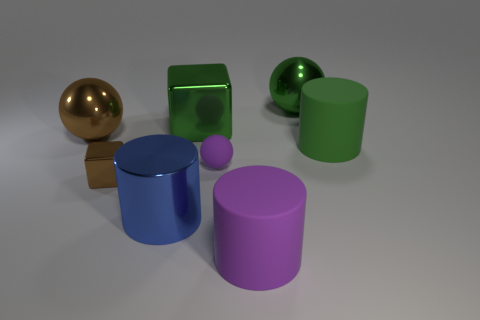What shape is the green shiny thing that is left of the big purple matte cylinder?
Your answer should be compact. Cube. Do the large shiny sphere to the left of the green shiny ball and the large sphere right of the small rubber thing have the same color?
Provide a short and direct response. No. What number of metallic cubes are in front of the large green metallic cube and right of the brown shiny block?
Make the answer very short. 0. The green object that is made of the same material as the purple ball is what size?
Keep it short and to the point. Large. What size is the green block?
Ensure brevity in your answer.  Large. What is the material of the blue object?
Ensure brevity in your answer.  Metal. There is a brown metallic thing that is in front of the green rubber cylinder; does it have the same size as the brown metallic ball?
Make the answer very short. No. What number of things are small blue metal objects or large balls?
Your answer should be very brief. 2. What is the shape of the metallic object that is the same color as the big metal block?
Provide a succinct answer. Sphere. There is a cylinder that is behind the purple matte cylinder and right of the blue cylinder; how big is it?
Make the answer very short. Large. 